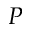<formula> <loc_0><loc_0><loc_500><loc_500>P</formula> 